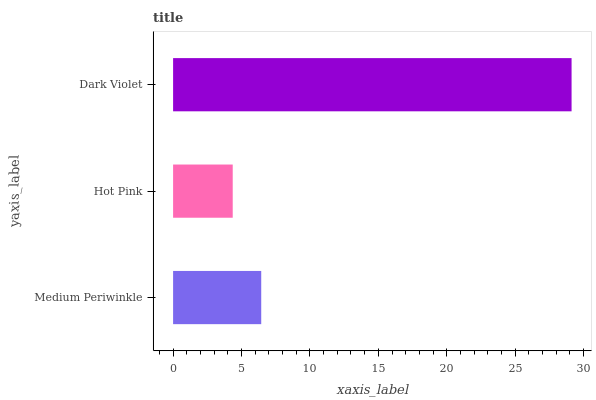Is Hot Pink the minimum?
Answer yes or no. Yes. Is Dark Violet the maximum?
Answer yes or no. Yes. Is Dark Violet the minimum?
Answer yes or no. No. Is Hot Pink the maximum?
Answer yes or no. No. Is Dark Violet greater than Hot Pink?
Answer yes or no. Yes. Is Hot Pink less than Dark Violet?
Answer yes or no. Yes. Is Hot Pink greater than Dark Violet?
Answer yes or no. No. Is Dark Violet less than Hot Pink?
Answer yes or no. No. Is Medium Periwinkle the high median?
Answer yes or no. Yes. Is Medium Periwinkle the low median?
Answer yes or no. Yes. Is Dark Violet the high median?
Answer yes or no. No. Is Hot Pink the low median?
Answer yes or no. No. 